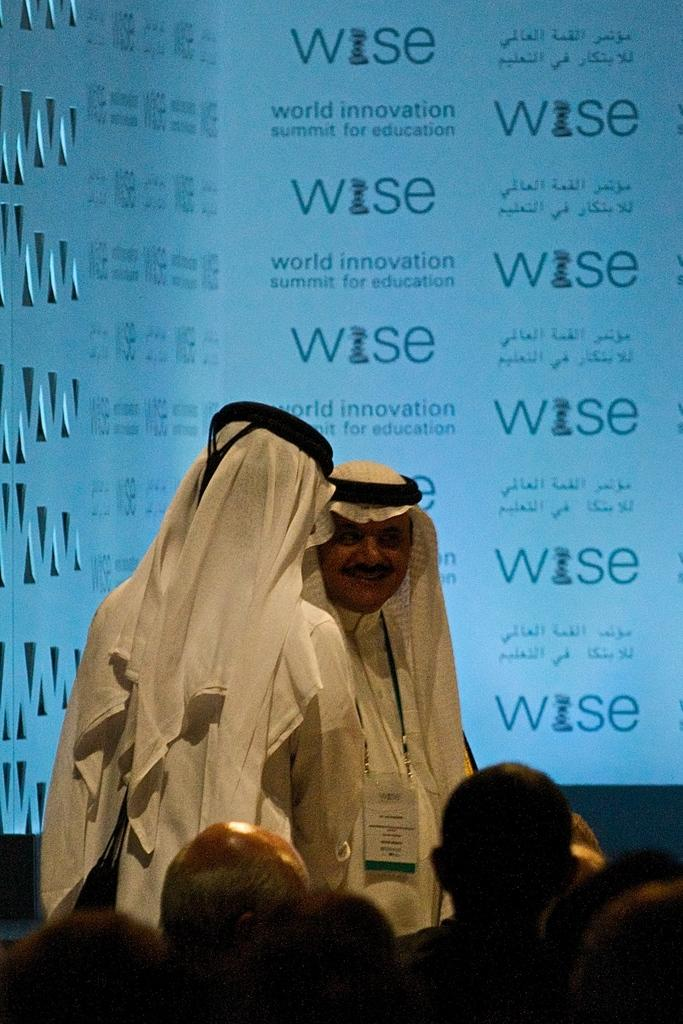Who is present in the image? There are people in the image. What are some of the men wearing? Some men in the image are wearing white clothes. What can be seen on the wall in the background of the image? There is something written on a wall in the background of the image. What type of juice is being served on the ground in the image? There is no juice or ground present in the image. 